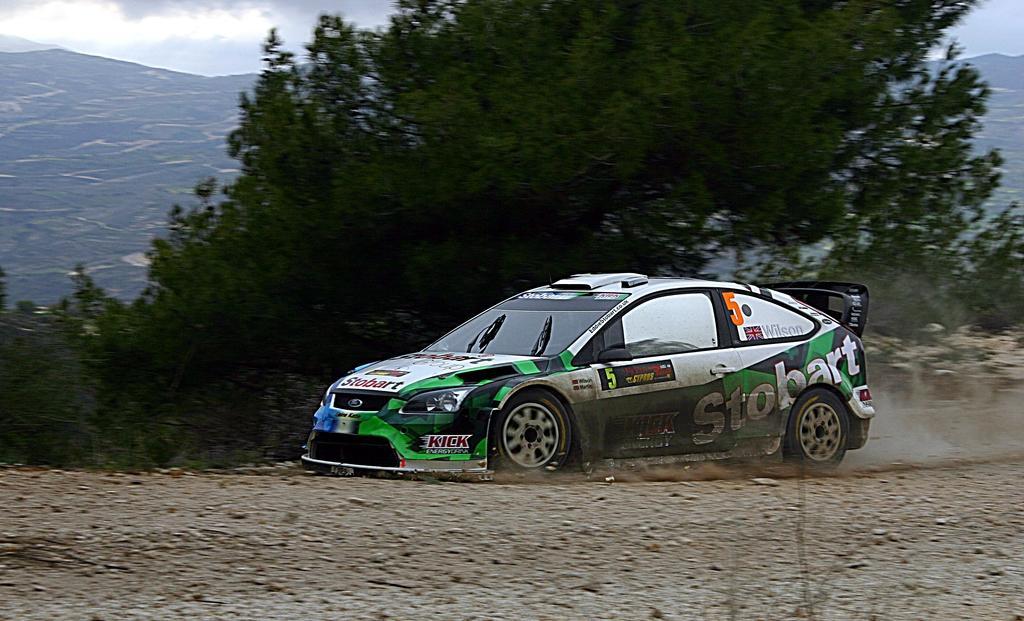Can you describe this image briefly? At the bottom of the image there is a ground. On the ground there is a car with names on it. Behind the car there are trees and also there are hills. In the background there is sky. 